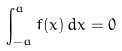Convert formula to latex. <formula><loc_0><loc_0><loc_500><loc_500>\int _ { - a } ^ { a } f ( x ) \, d x = 0</formula> 